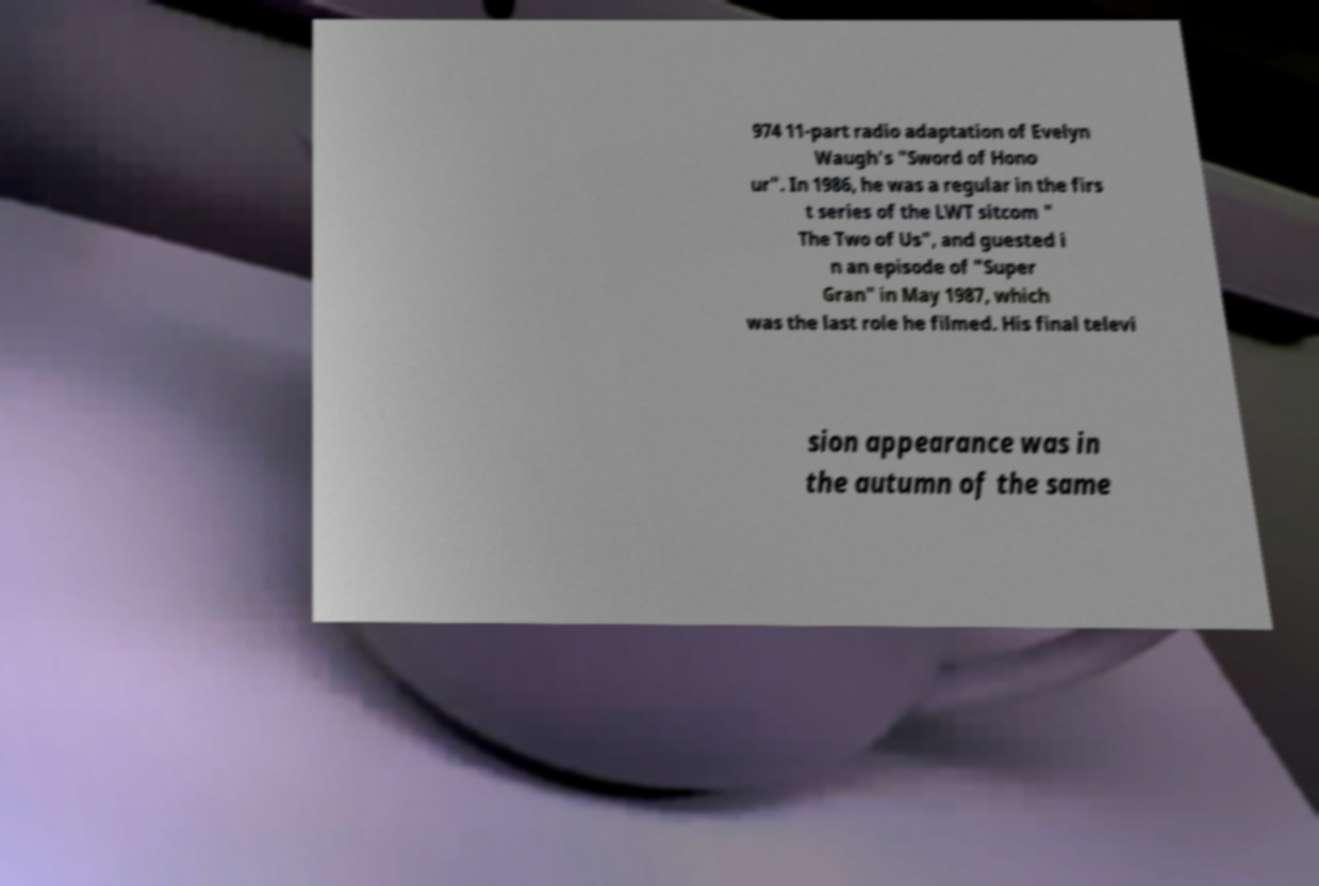Can you accurately transcribe the text from the provided image for me? 974 11-part radio adaptation of Evelyn Waugh's "Sword of Hono ur". In 1986, he was a regular in the firs t series of the LWT sitcom " The Two of Us", and guested i n an episode of "Super Gran" in May 1987, which was the last role he filmed. His final televi sion appearance was in the autumn of the same 